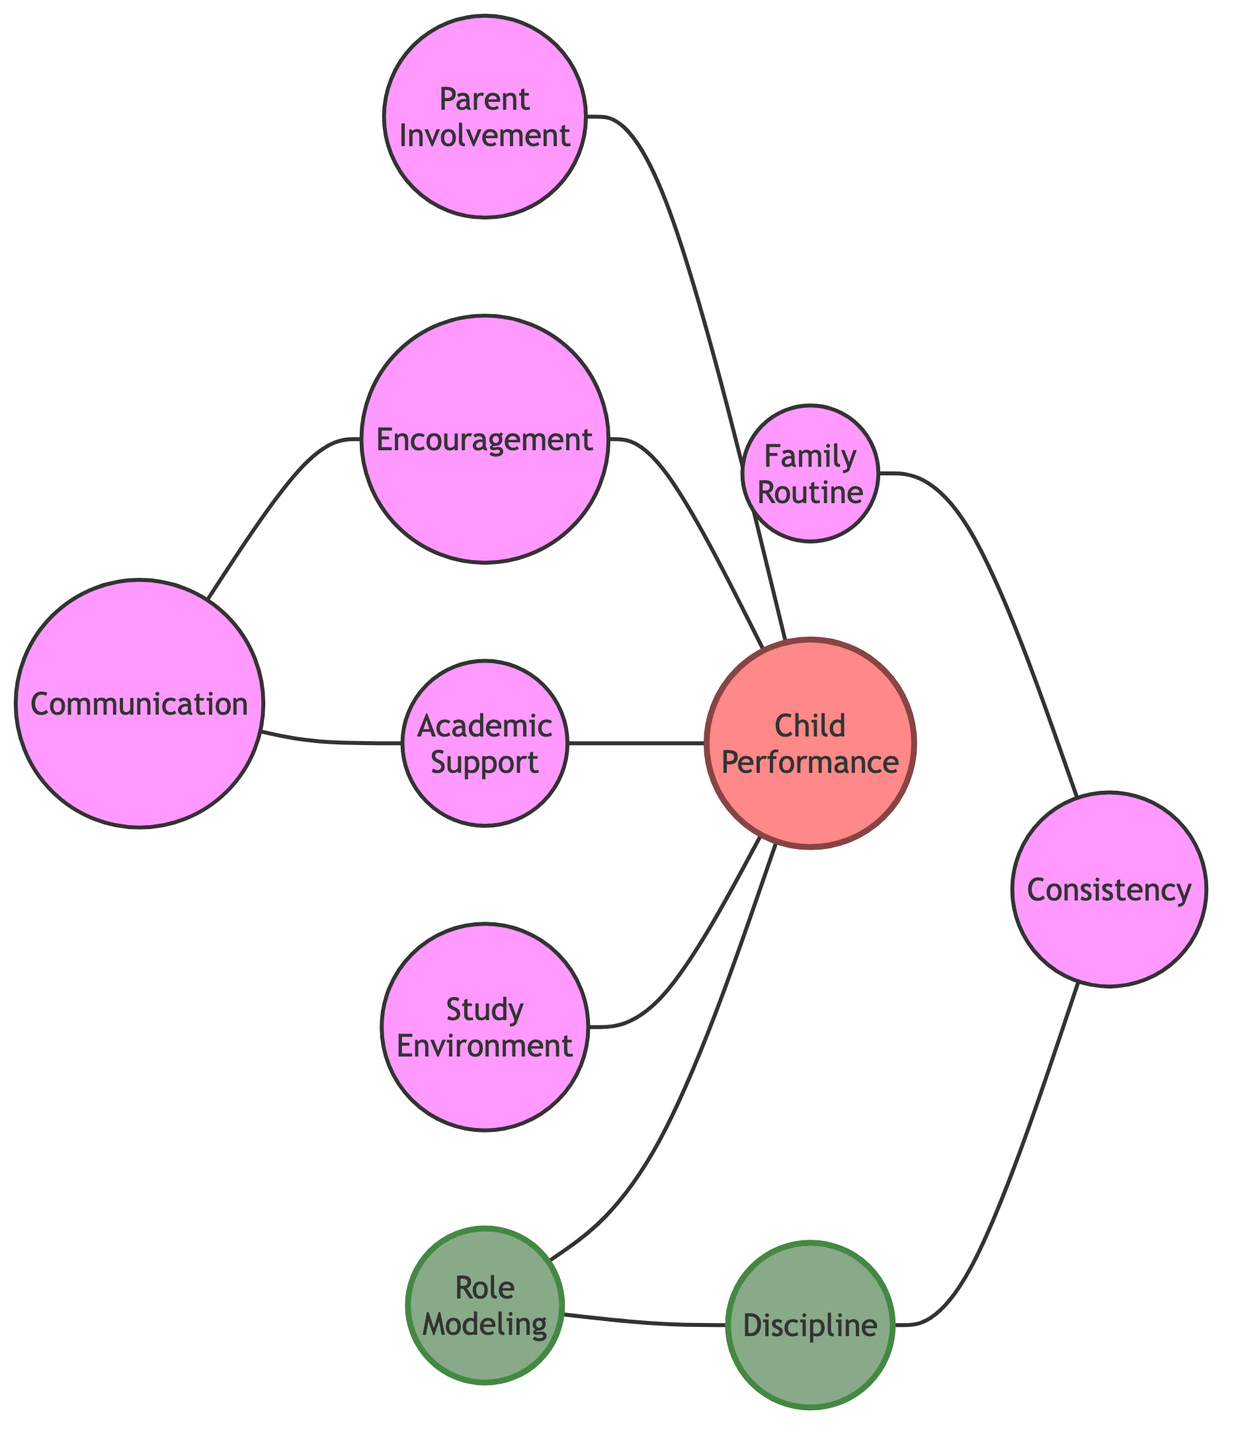What is the total number of nodes in the diagram? Counting the nodes listed in the data, there are ten distinct entities: Parent Involvement, Family Routine, Academic Support, Discipline, Child Performance, Encouragement, Study Environment, Role Modeling, Communication, and Consistency.
Answer: ten Which node is directly connected to Child Performance? Looking at the edges, the nodes that connect directly to Child Performance are Parent Involvement, Academic Support, Encouragement, Study Environment, and Role Modeling.
Answer: five What is the relationship between Communication and Academic Support? The edge connects Communication to Academic Support, indicating that Communication is a factor influencing or providing support to Academic Support.
Answer: influencing How many edges are there in the graph? The edges present in the diagram include connections from Parent Involvement to Child Performance, etc. By counting these connections, there are ten edges in total.
Answer: ten Which node contributes to both Discipline and Child Performance? The Role Modeling node is connected to both Discipline and Child Performance. This shows it has a dual influence on different aspects of study habits and outcomes.
Answer: Role Modeling What is the most common outcome node related to the edges? Child Performance is the only node that connects with multiple other nodes, specifically five, indicating it is a central outcome in this model of study habits.
Answer: Child Performance Which nodes are influenced by Communication? The edges show that Communication influences both Encouragement and Academic Support, indicating these are key areas where effective communication plays a role.
Answer: Encouragement and Academic Support What is the role of Family Routine in relation to consistency? Family Routine connects to Consistency as a contributing factor, indicating that having a structured family routine helps promote consistency in study habits.
Answer: contributing factor What two nodes does Role Modeling connect to? The Role Modeling node connects to Child Performance and Discipline, indicating its influence on both the expected performance of the child and the establishment of discipline.
Answer: Child Performance and Discipline 